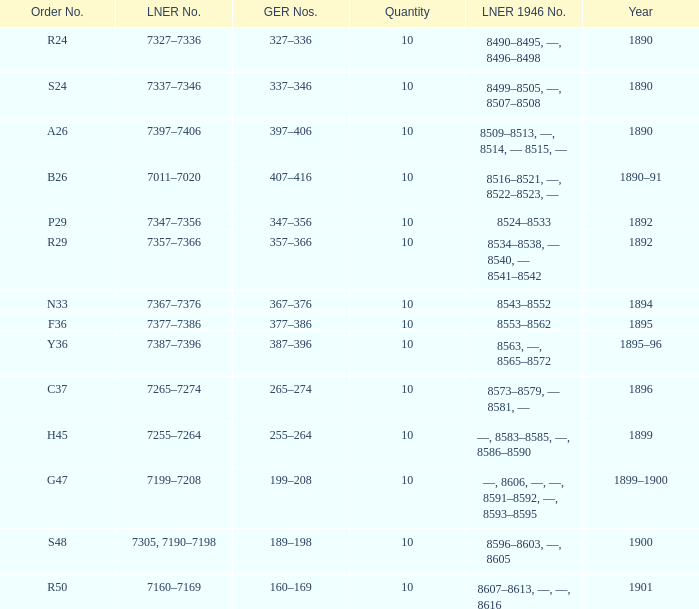Which LNER 1946 number is from 1892 and has an LNER number of 7347–7356? 8524–8533. 